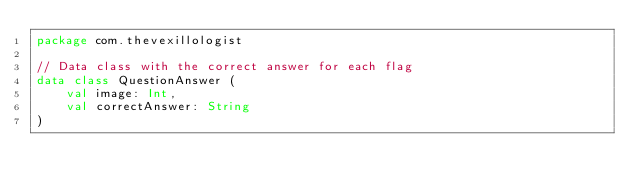Convert code to text. <code><loc_0><loc_0><loc_500><loc_500><_Kotlin_>package com.thevexillologist

// Data class with the correct answer for each flag
data class QuestionAnswer (
    val image: Int,
    val correctAnswer: String
)</code> 